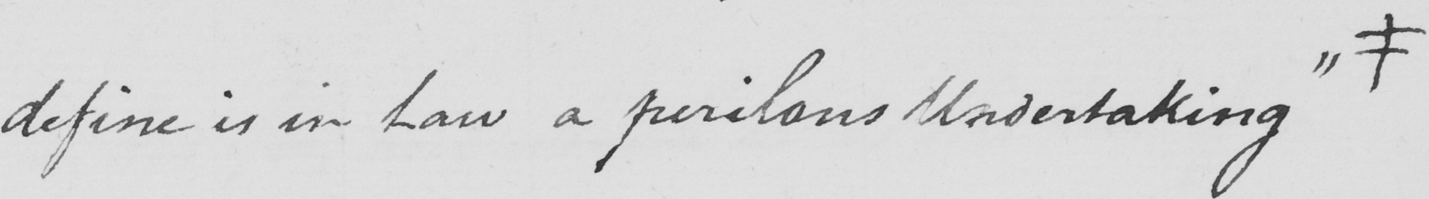Transcribe the text shown in this historical manuscript line. define is in Law a perilous Undertaking "  # 